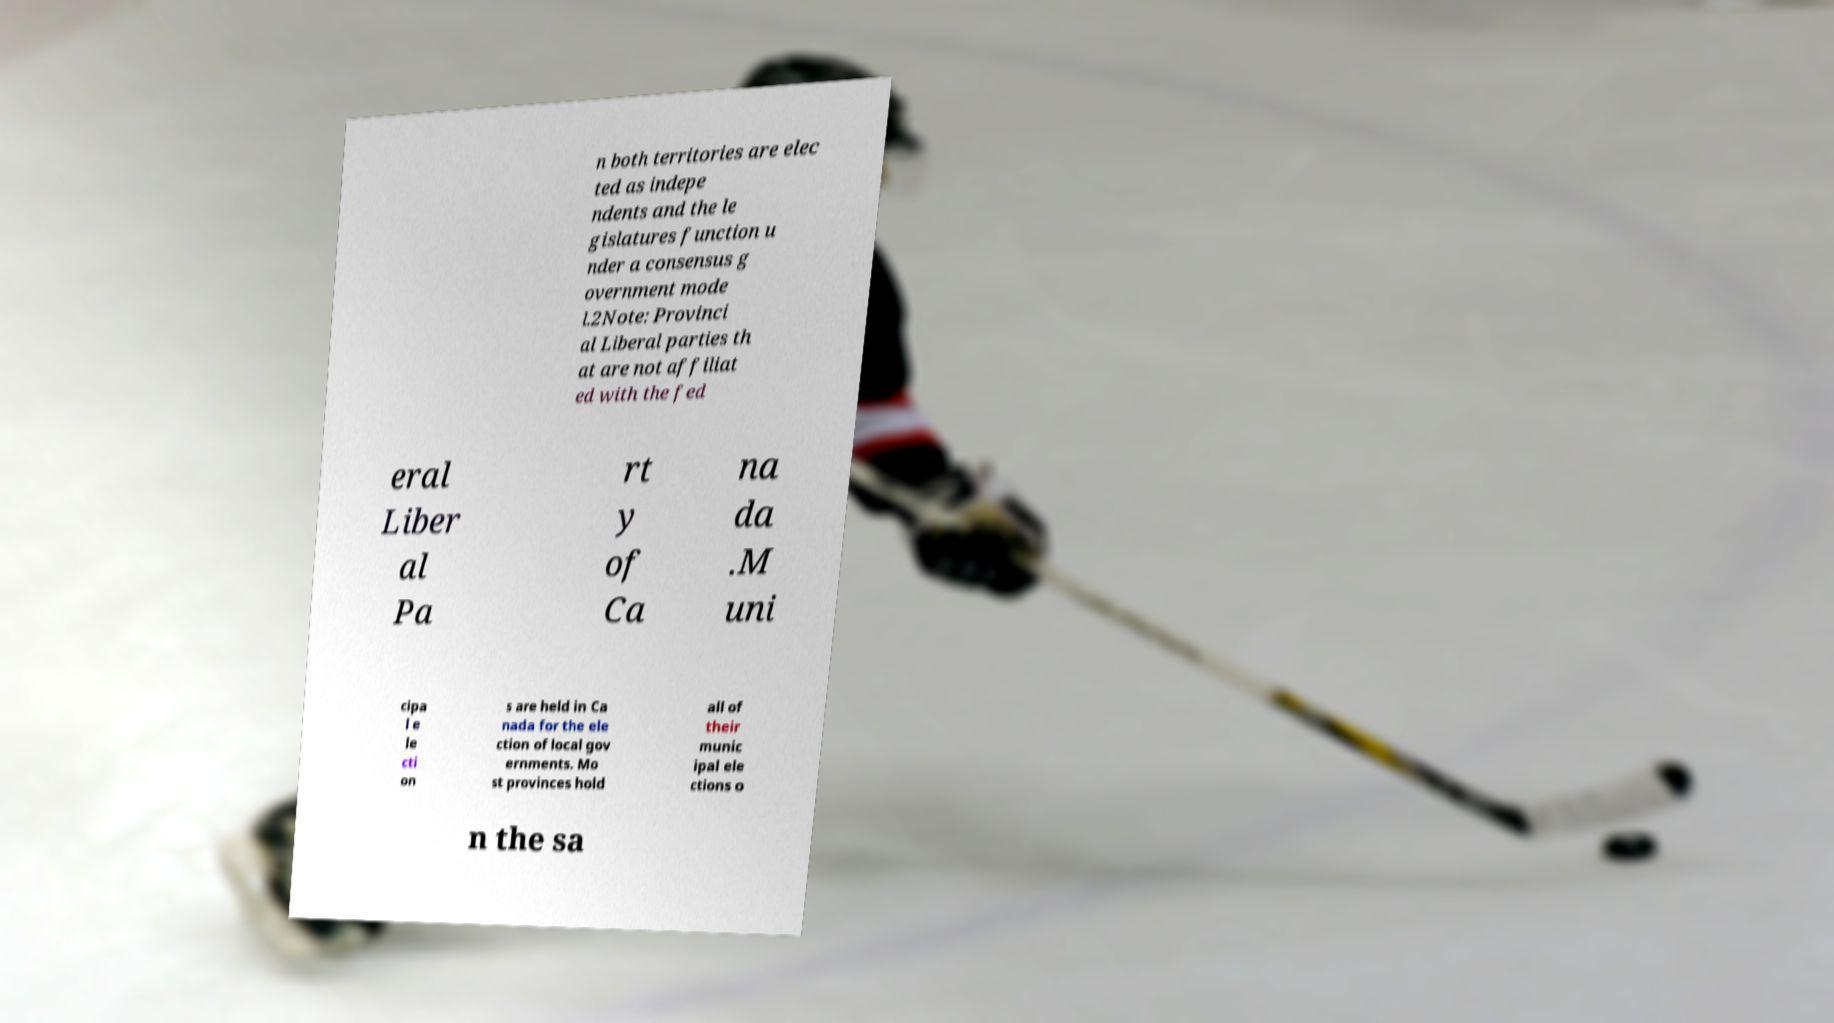I need the written content from this picture converted into text. Can you do that? n both territories are elec ted as indepe ndents and the le gislatures function u nder a consensus g overnment mode l.2Note: Provinci al Liberal parties th at are not affiliat ed with the fed eral Liber al Pa rt y of Ca na da .M uni cipa l e le cti on s are held in Ca nada for the ele ction of local gov ernments. Mo st provinces hold all of their munic ipal ele ctions o n the sa 